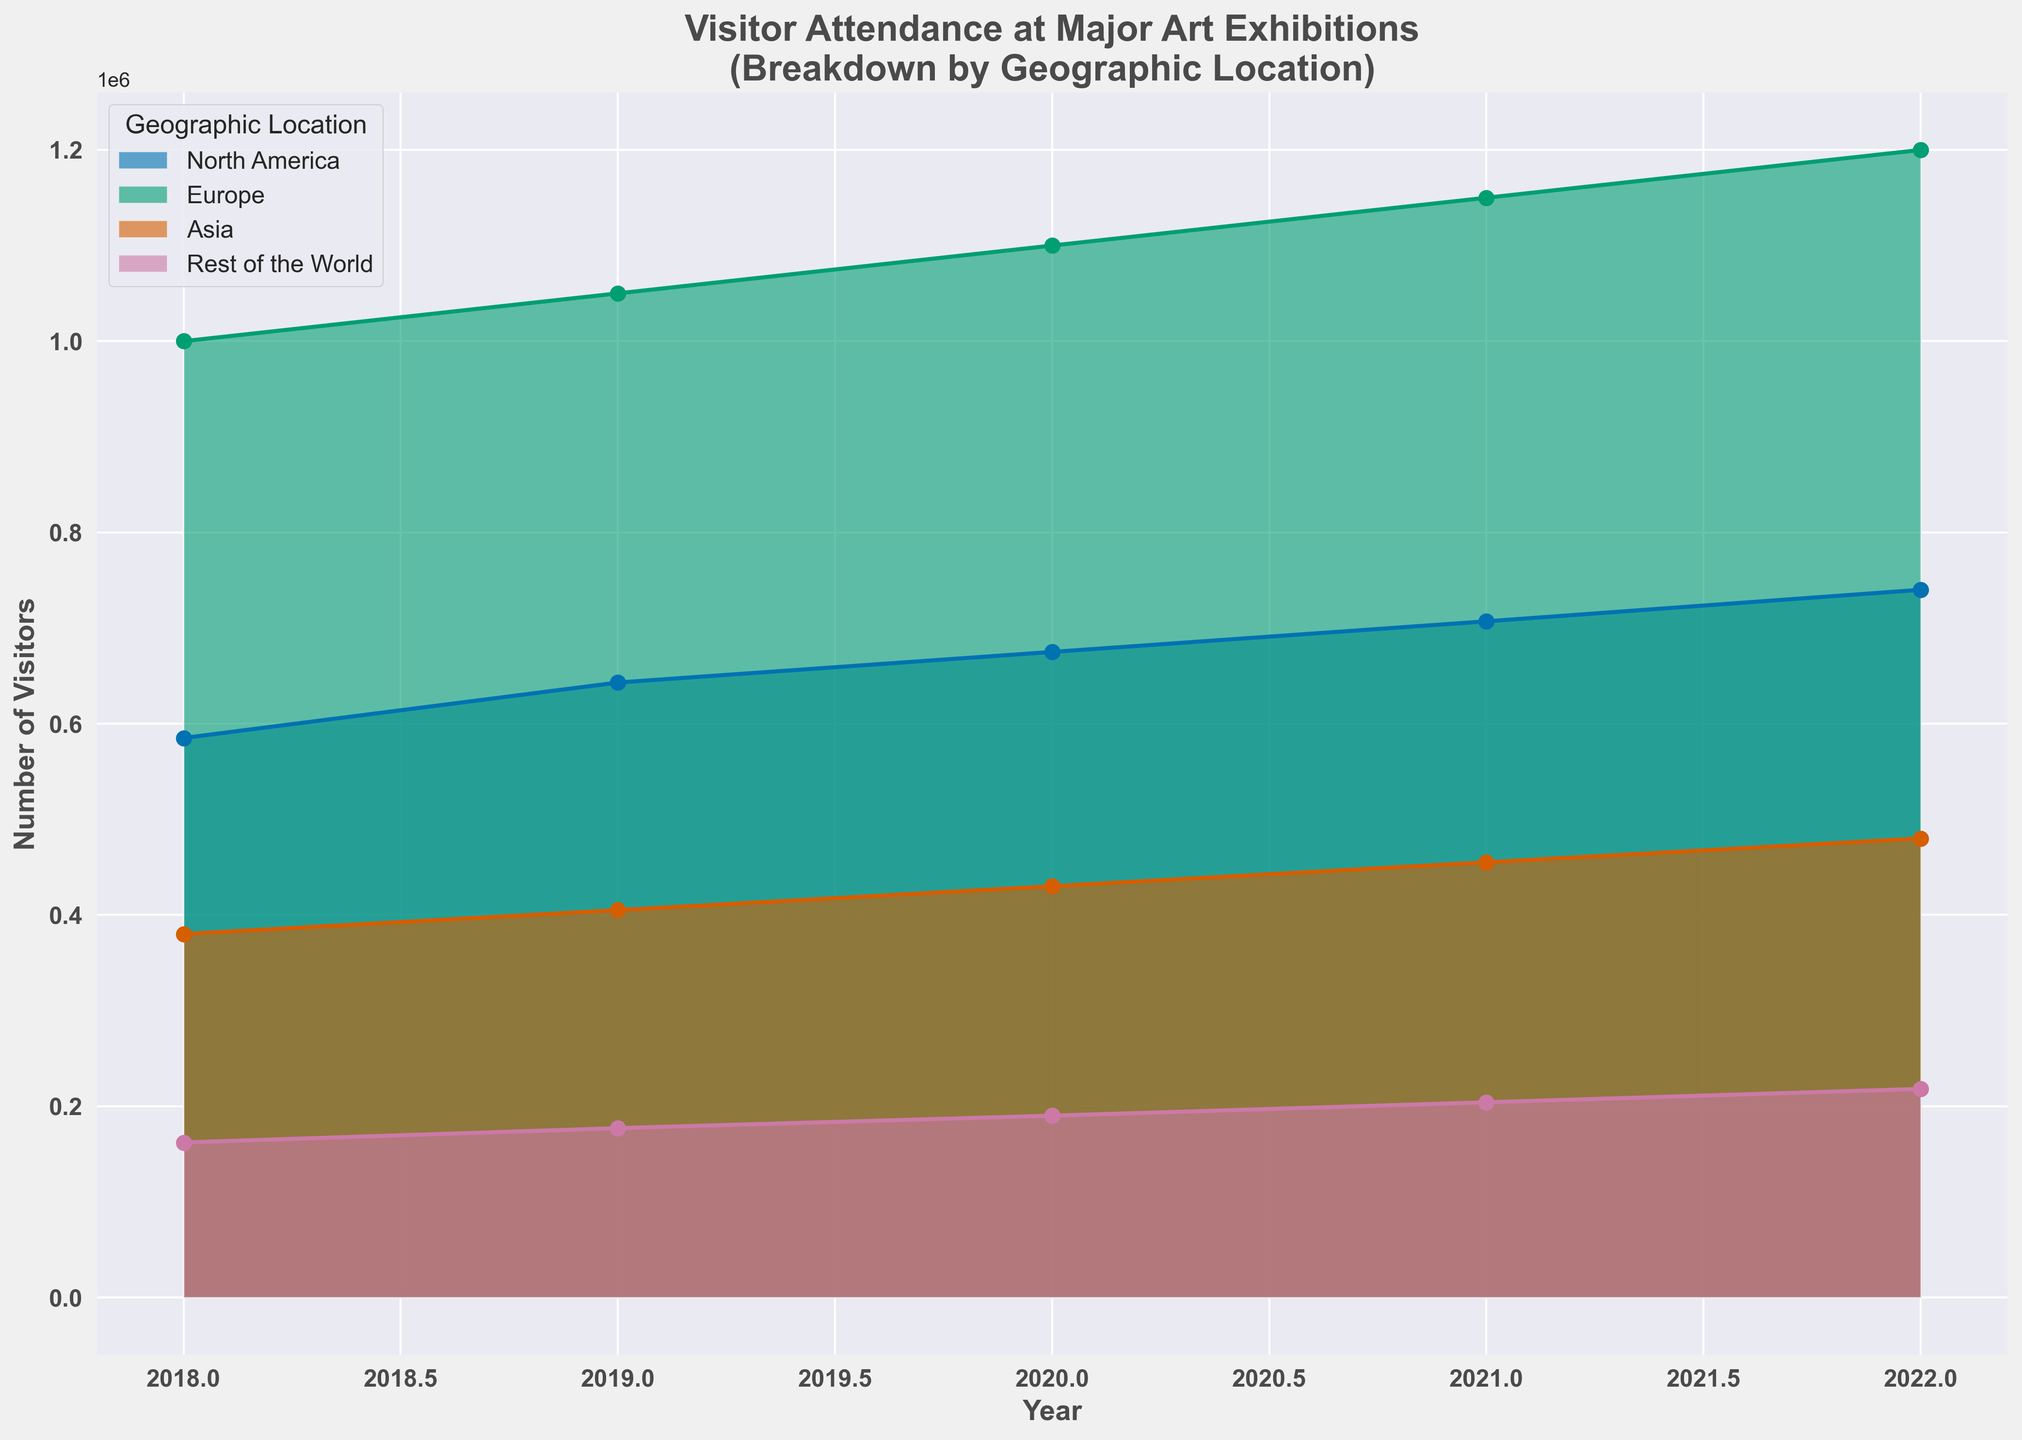what is the total attendance across all geographic locations for the Renaissance Collections in 2022? To find the total attendance across all locations for the Renaissance Collections in 2022, add the numbers of visitors from all regions: North America (105,000) + Europe (280,000) + Asia (80,000) + Rest of the World (60,000) = 525,000
Answer: 525,000 Which geographic location had the highest visitor attendance for Modern Art Showcase in 2021? For the Modern Art Showcase in 2021, compare the visitor numbers of each location: North America (165,000), Europe (210,000), Asia (105,000), Rest of the World (40,000). Europe had the highest attendance.
Answer: Europe How did visitor attendance for Contemporary Masters in North America change from 2019 to 2022? For Contemporary Masters in North America, look at the visitor numbers for 2019 (135,000) and 2022 (150,000). Calculate the difference: 150,000 - 135,000 = 15,000. The attendance increased by 15,000.
Answer: Increased by 15,000 What was the average number of visitors from Asia for the Impressionist Paintings exhibition across all years? Add the visitor numbers from Asia for the Impressionist Paintings across all years: 75,000 (2018) + 80,000 (2019) + 85,000 (2020) + 90,000 (2021) + 95,000 (2022) = 425,000. Divide by the number of years (5): 425,000 / 5 = 85,000
Answer: 85,000 Did the visitor attendance in Europe for Abstract Art Gala ever drop from one year to the next? Check the visitor numbers in Europe for Abstract Art Gala for each year: 160,000 (2018), 170,000 (2019), 180,000 (2020), 190,000 (2021), 200,000 (2022). The attendance never dropped any year from the previous one.
Answer: No Which exhibition had the lowest attendance in North America in 2018? Compare visitor numbers in North America for all exhibitions in 2018: Impressionist Paintings (120,000), Modern Art Showcase (135,000), Abstract Art Gala (110,000), Renaissance Collections (95,000), Contemporary Masters (125,000). Renaissance Collections had the lowest attendance.
Answer: Renaissance Collections If you sum the visitor attendance from the Rest of the World for all exhibitions in 2020, what is the total? Add the visitor numbers from the Rest of the World for all exhibitions in 2020: Impressionist Paintings (40,000) + Modern Art Showcase (38,000) + Abstract Art Gala (27,000) + Renaissance Collections (50,000) + Contemporary Masters (35,000) = 190,000
Answer: 190,000 